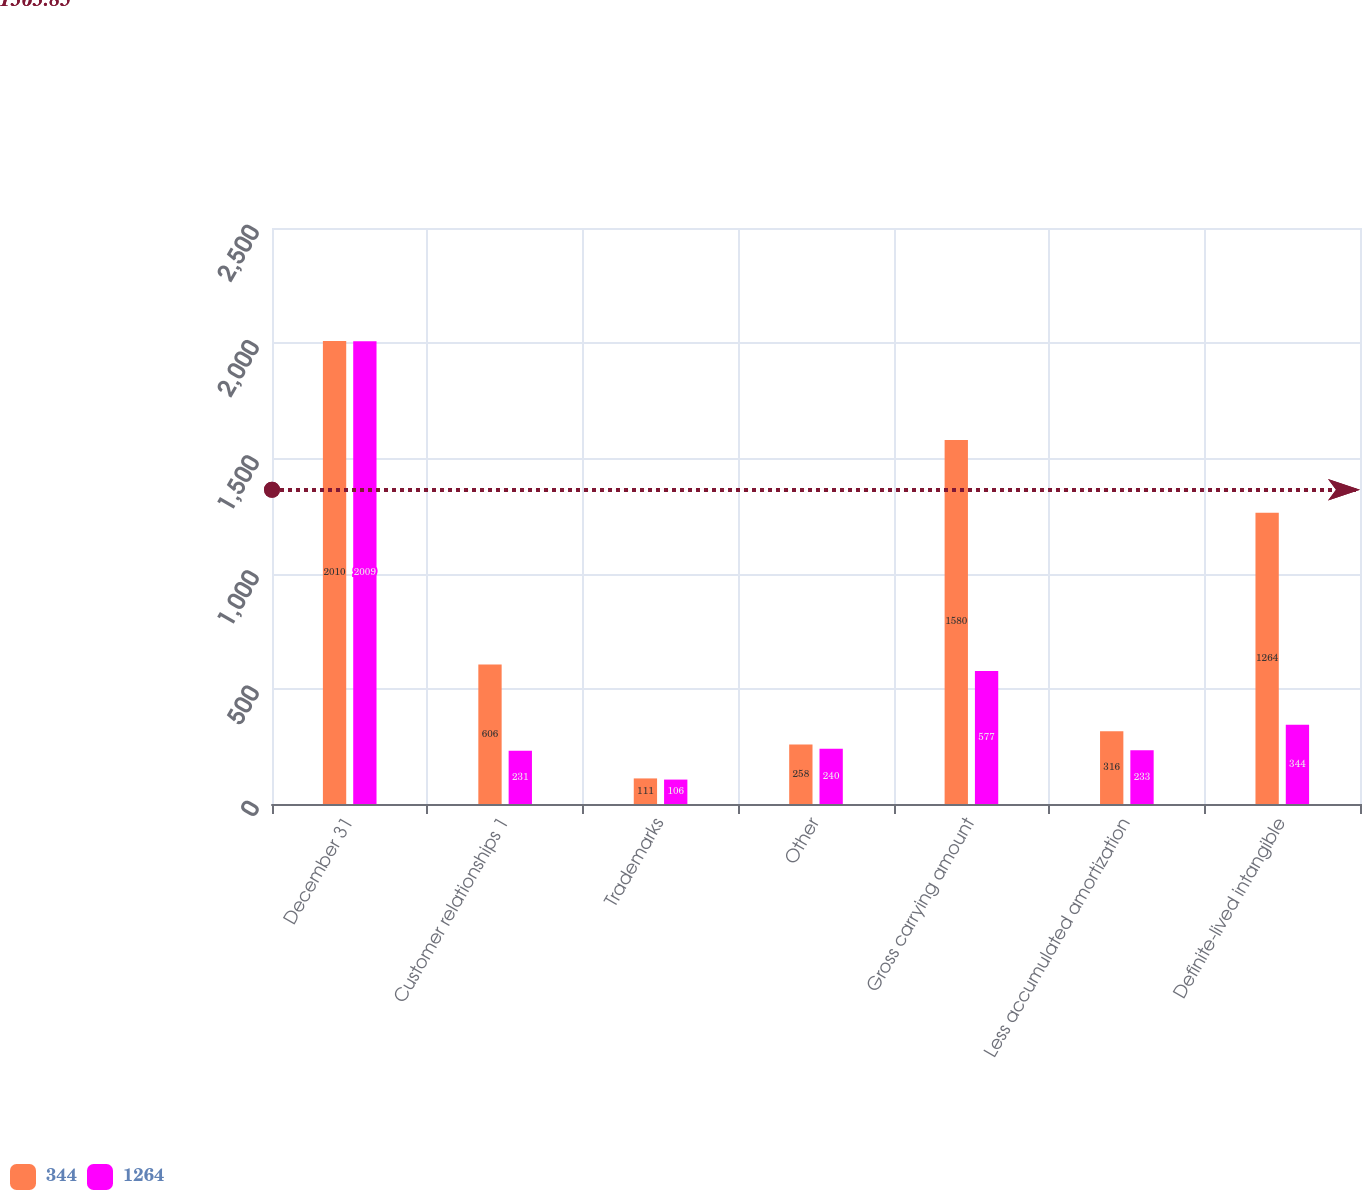Convert chart. <chart><loc_0><loc_0><loc_500><loc_500><stacked_bar_chart><ecel><fcel>December 31<fcel>Customer relationships 1<fcel>Trademarks<fcel>Other<fcel>Gross carrying amount<fcel>Less accumulated amortization<fcel>Definite-lived intangible<nl><fcel>344<fcel>2010<fcel>606<fcel>111<fcel>258<fcel>1580<fcel>316<fcel>1264<nl><fcel>1264<fcel>2009<fcel>231<fcel>106<fcel>240<fcel>577<fcel>233<fcel>344<nl></chart> 